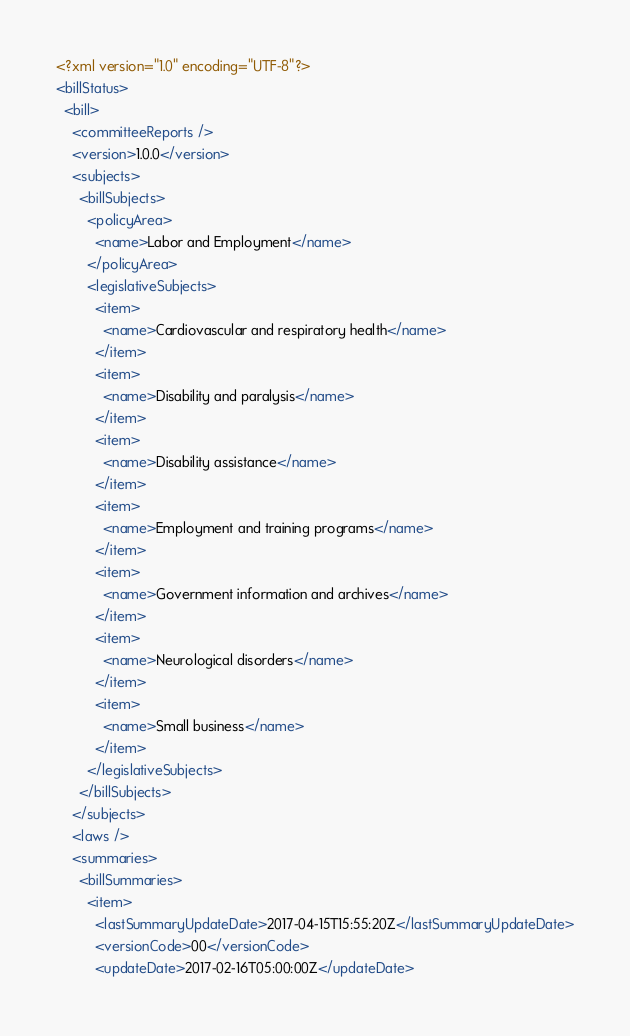Convert code to text. <code><loc_0><loc_0><loc_500><loc_500><_XML_><?xml version="1.0" encoding="UTF-8"?>
<billStatus>
  <bill>
    <committeeReports />
    <version>1.0.0</version>
    <subjects>
      <billSubjects>
        <policyArea>
          <name>Labor and Employment</name>
        </policyArea>
        <legislativeSubjects>
          <item>
            <name>Cardiovascular and respiratory health</name>
          </item>
          <item>
            <name>Disability and paralysis</name>
          </item>
          <item>
            <name>Disability assistance</name>
          </item>
          <item>
            <name>Employment and training programs</name>
          </item>
          <item>
            <name>Government information and archives</name>
          </item>
          <item>
            <name>Neurological disorders</name>
          </item>
          <item>
            <name>Small business</name>
          </item>
        </legislativeSubjects>
      </billSubjects>
    </subjects>
    <laws />
    <summaries>
      <billSummaries>
        <item>
          <lastSummaryUpdateDate>2017-04-15T15:55:20Z</lastSummaryUpdateDate>
          <versionCode>00</versionCode>
          <updateDate>2017-02-16T05:00:00Z</updateDate></code> 